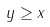Convert formula to latex. <formula><loc_0><loc_0><loc_500><loc_500>y \geq x</formula> 